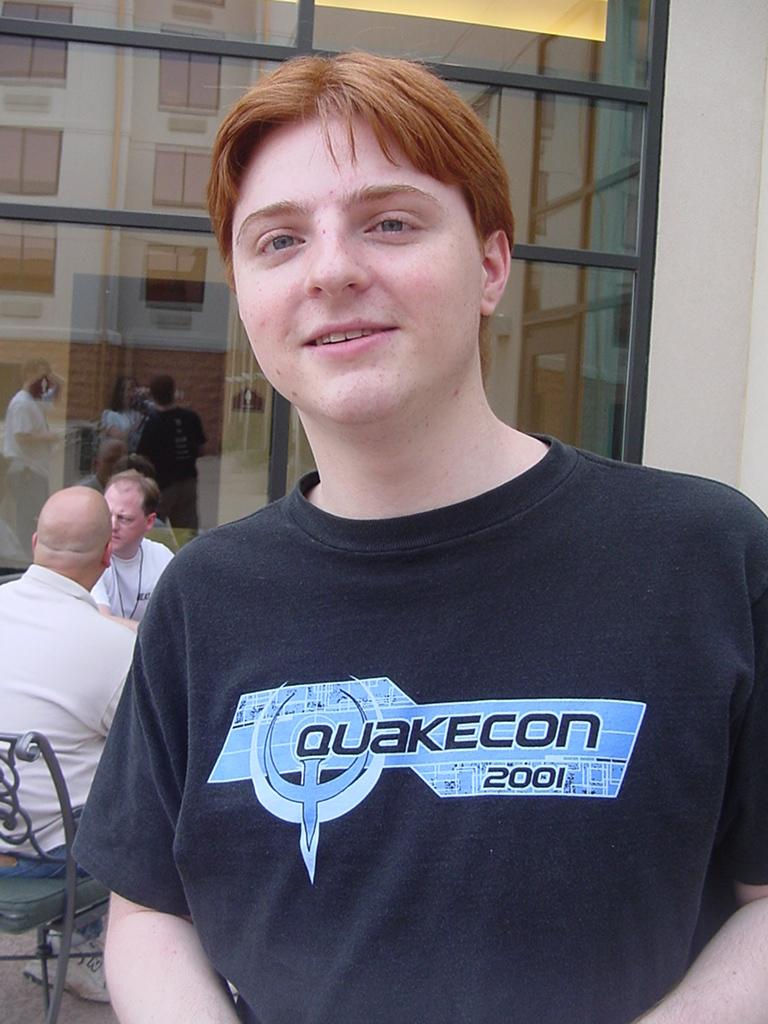Provide a one-sentence caption for the provided image. Quakecon is being advertised on the boy's shirt. 